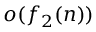Convert formula to latex. <formula><loc_0><loc_0><loc_500><loc_500>o ( f _ { 2 } ( n ) )</formula> 